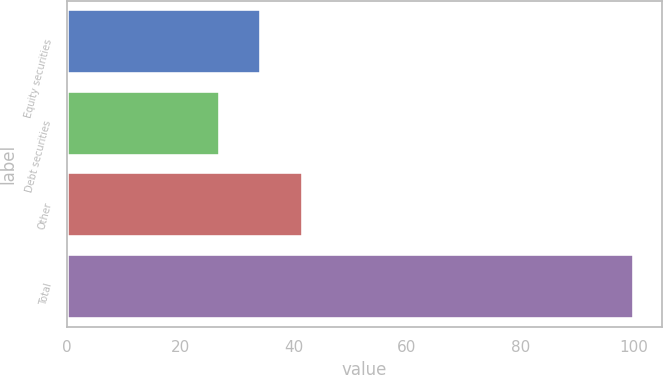<chart> <loc_0><loc_0><loc_500><loc_500><bar_chart><fcel>Equity securities<fcel>Debt securities<fcel>Other<fcel>Total<nl><fcel>34.3<fcel>27<fcel>41.6<fcel>100<nl></chart> 